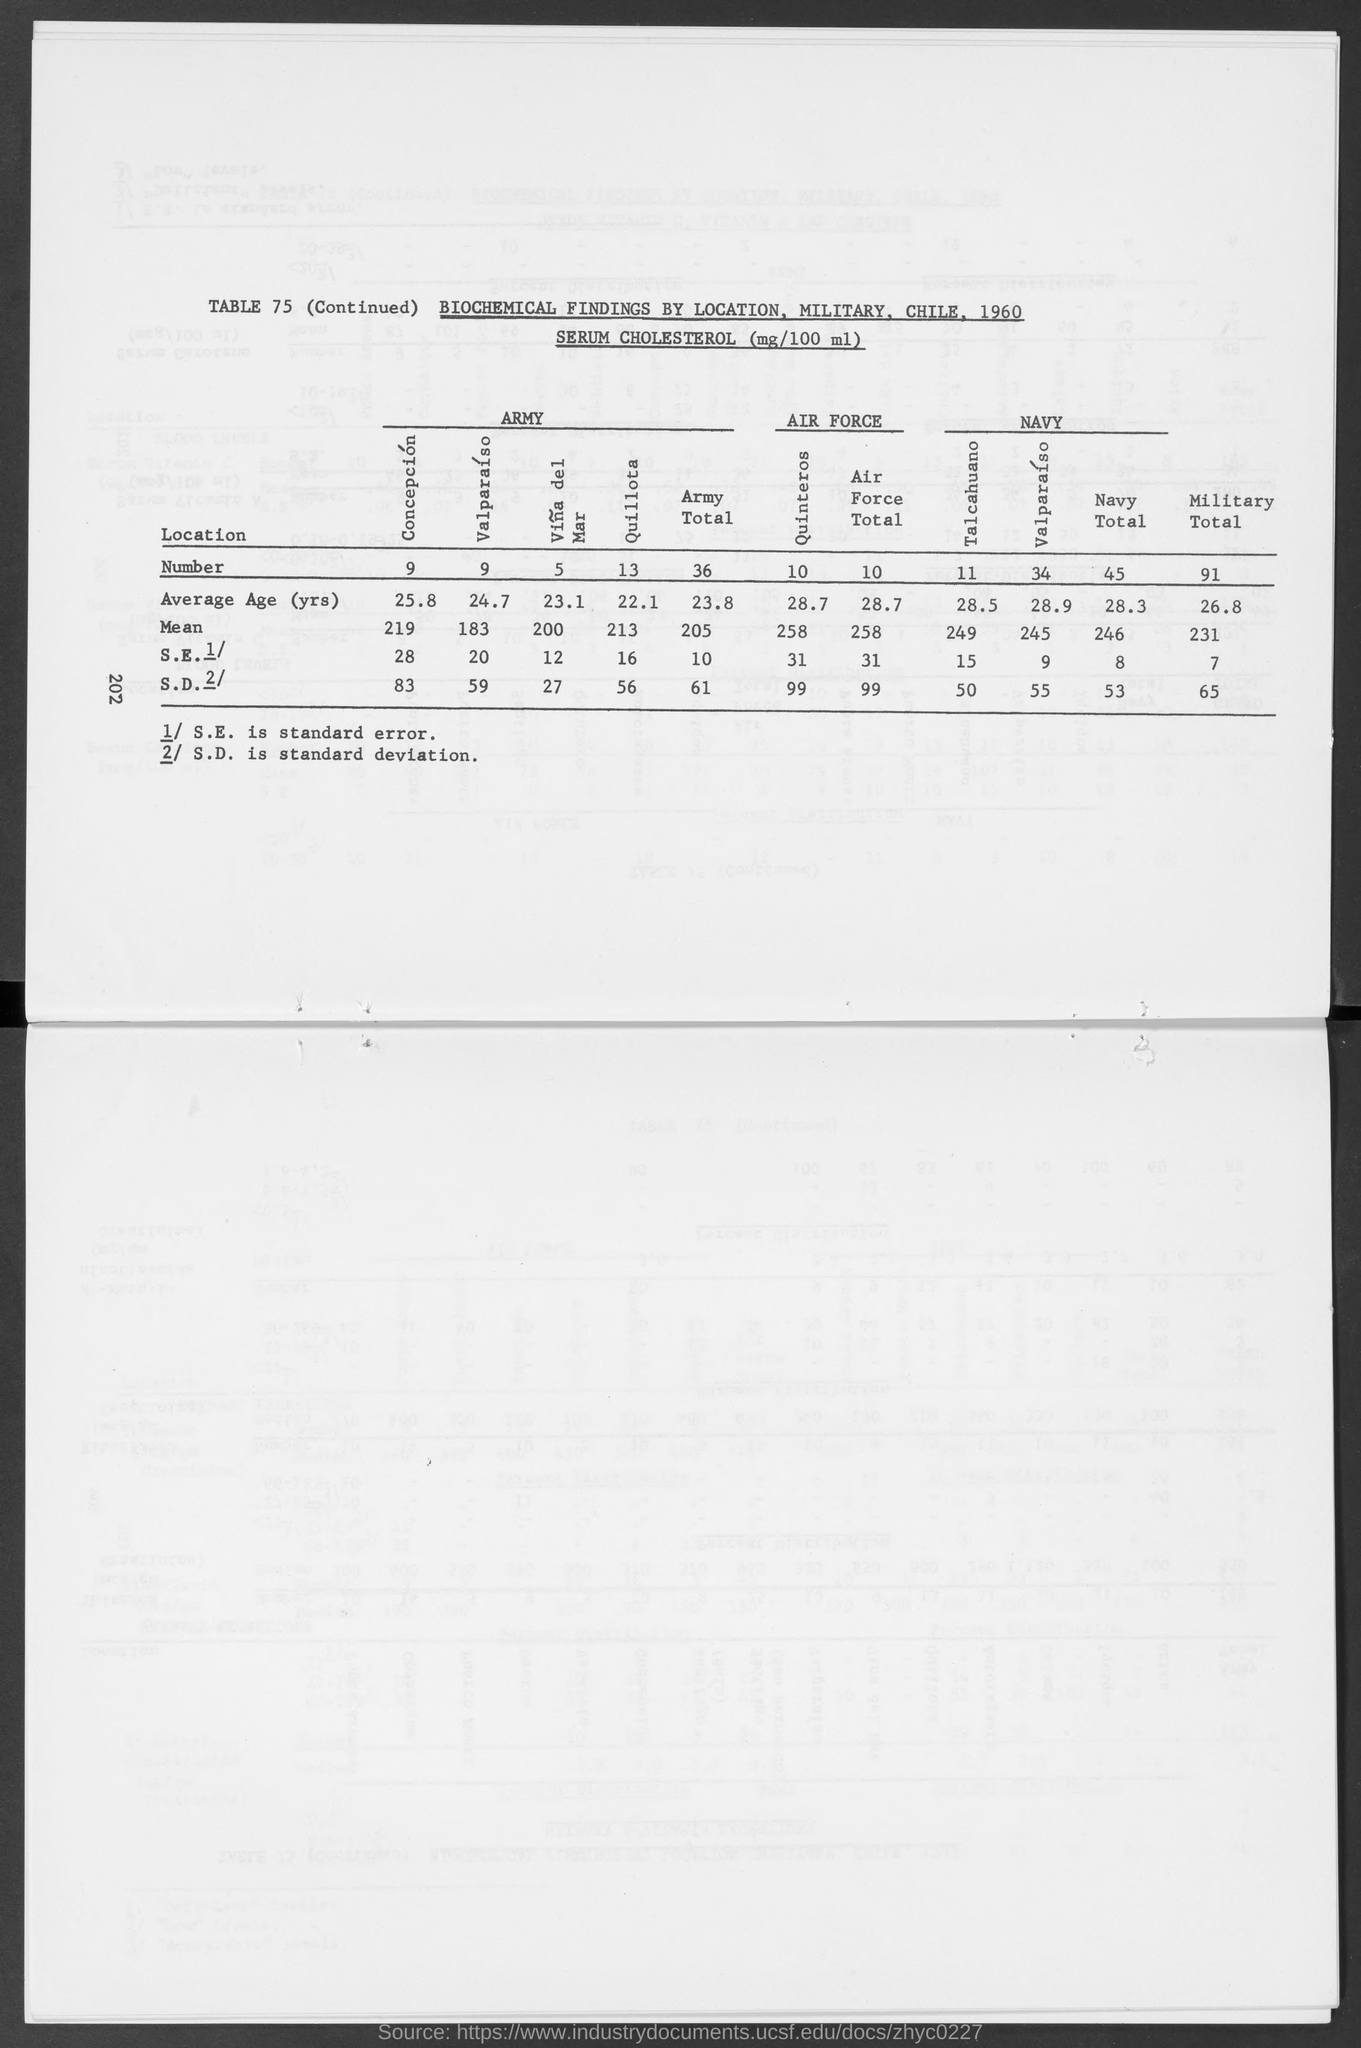What is the unit of SERUM CHOLESTEROL?
Give a very brief answer. (mg/100 ml). What does S.E. stand for?
Your response must be concise. Standard error. What does S.D. denote?
Your answer should be very brief. Standard deviation. 